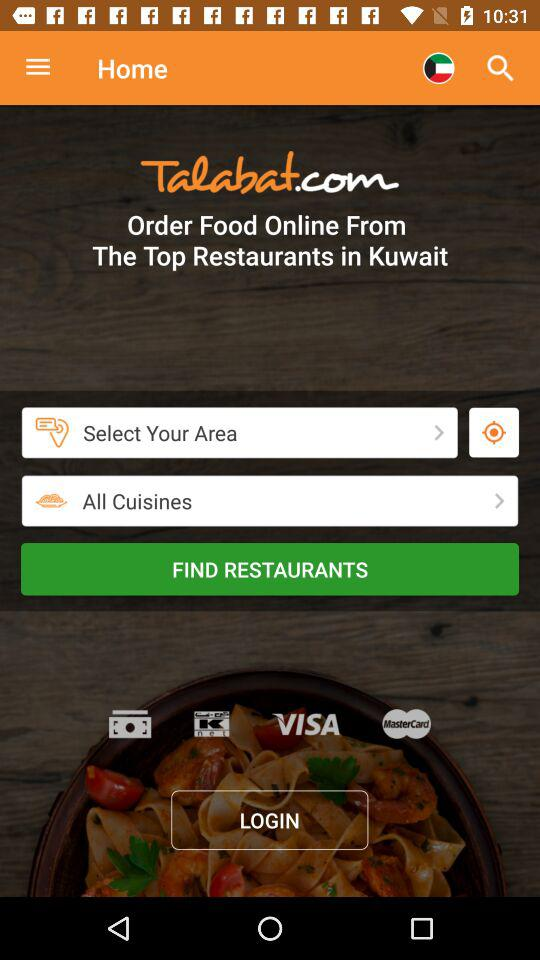What is the location of the restaurant? The location of the restaurant is Kuwait. 